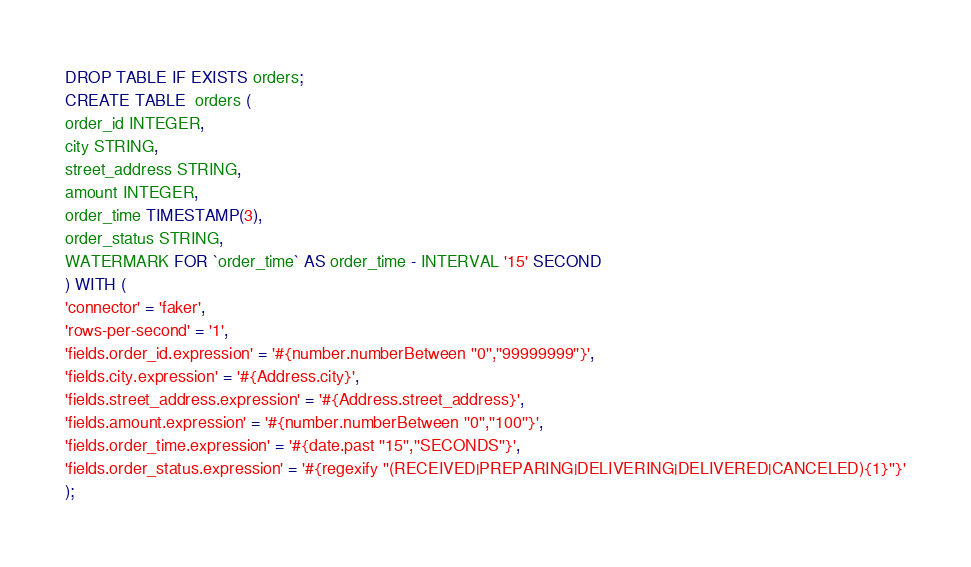Convert code to text. <code><loc_0><loc_0><loc_500><loc_500><_SQL_>DROP TABLE IF EXISTS orders;
CREATE TABLE  orders (
order_id INTEGER,
city STRING,
street_address STRING,
amount INTEGER,
order_time TIMESTAMP(3),
order_status STRING,
WATERMARK FOR `order_time` AS order_time - INTERVAL '15' SECOND
) WITH (
'connector' = 'faker',
'rows-per-second' = '1',
'fields.order_id.expression' = '#{number.numberBetween ''0'',''99999999''}',
'fields.city.expression' = '#{Address.city}',
'fields.street_address.expression' = '#{Address.street_address}',
'fields.amount.expression' = '#{number.numberBetween ''0'',''100''}',
'fields.order_time.expression' = '#{date.past ''15'',''SECONDS''}',
'fields.order_status.expression' = '#{regexify ''(RECEIVED|PREPARING|DELIVERING|DELIVERED|CANCELED){1}''}'
);
</code> 